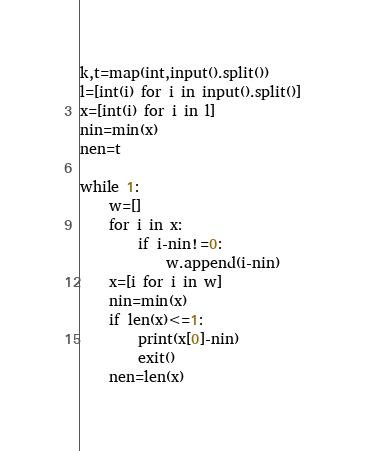<code> <loc_0><loc_0><loc_500><loc_500><_Python_>k,t=map(int,input().split())
l=[int(i) for i in input().split()]
x=[int(i) for i in l]
nin=min(x)
nen=t

while 1:
    w=[]
    for i in x:
        if i-nin!=0:
            w.append(i-nin)
    x=[i for i in w]
    nin=min(x)
    if len(x)<=1:
        print(x[0]-nin)
        exit()
    nen=len(x)</code> 